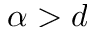<formula> <loc_0><loc_0><loc_500><loc_500>\alpha > d</formula> 